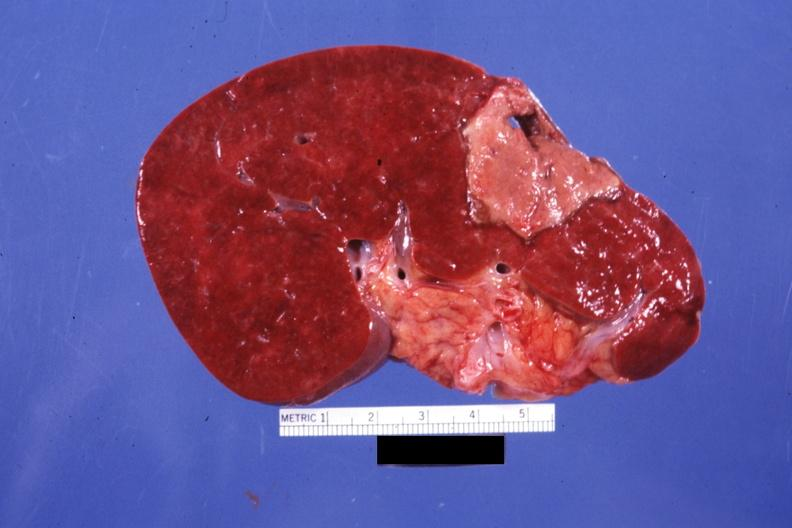what is present?
Answer the question using a single word or phrase. Hematologic 